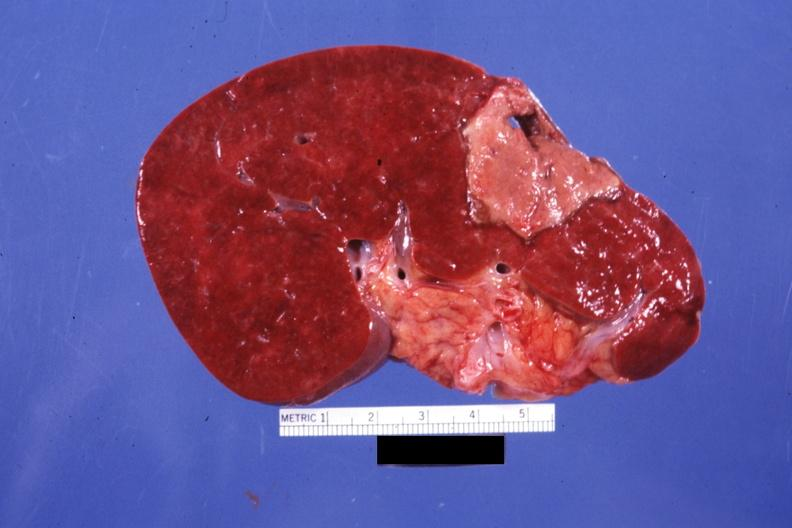what is present?
Answer the question using a single word or phrase. Hematologic 